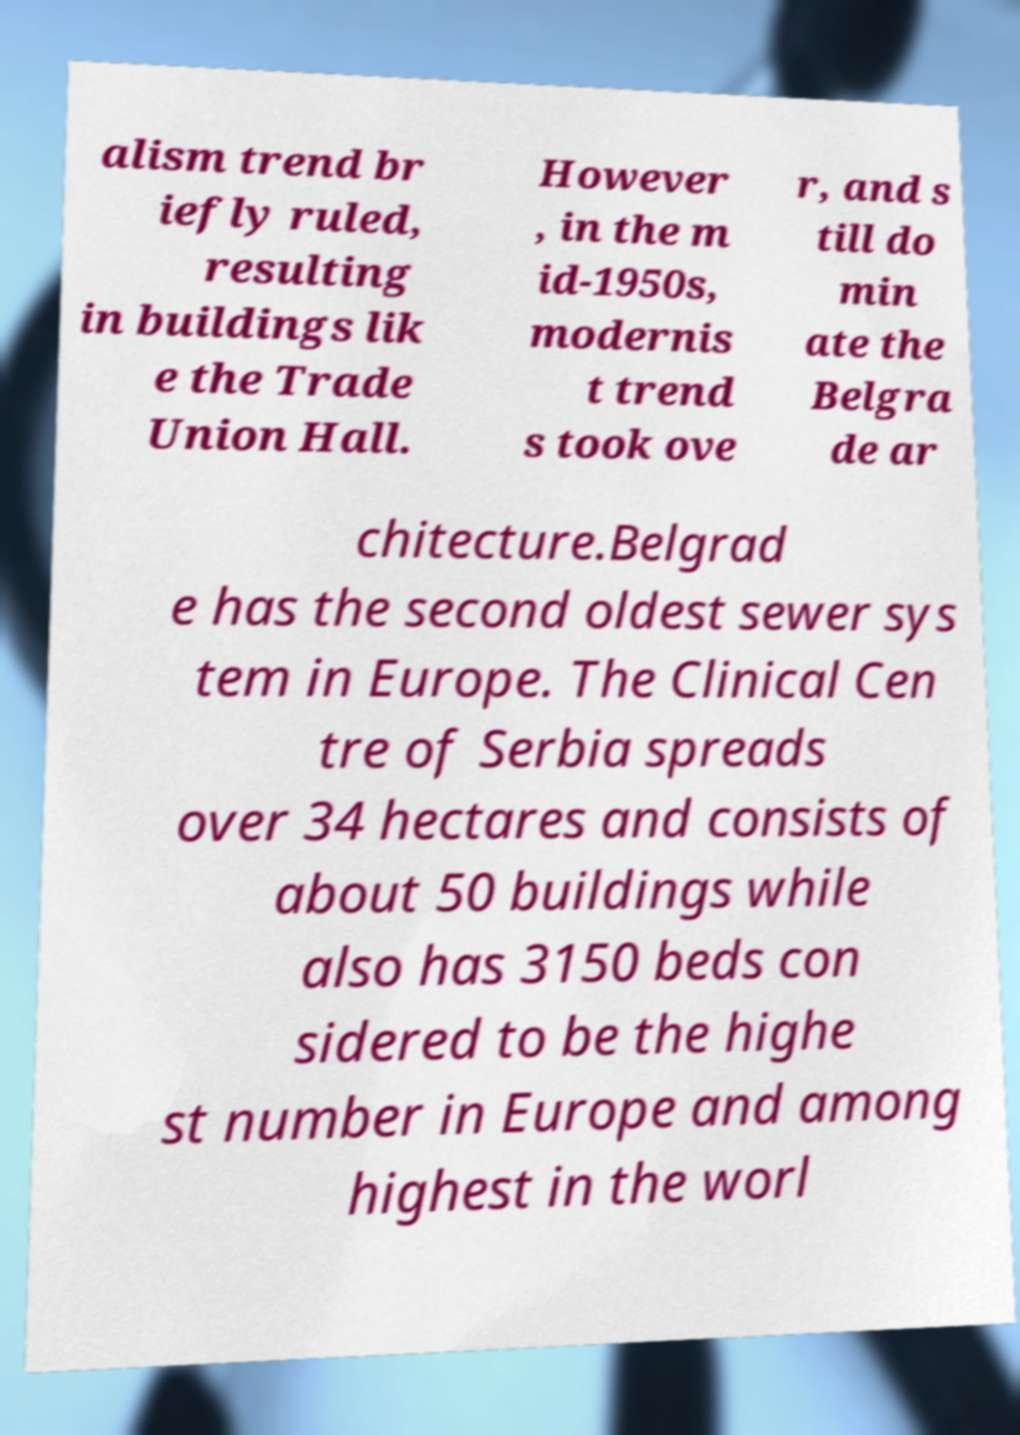Can you accurately transcribe the text from the provided image for me? alism trend br iefly ruled, resulting in buildings lik e the Trade Union Hall. However , in the m id-1950s, modernis t trend s took ove r, and s till do min ate the Belgra de ar chitecture.Belgrad e has the second oldest sewer sys tem in Europe. The Clinical Cen tre of Serbia spreads over 34 hectares and consists of about 50 buildings while also has 3150 beds con sidered to be the highe st number in Europe and among highest in the worl 